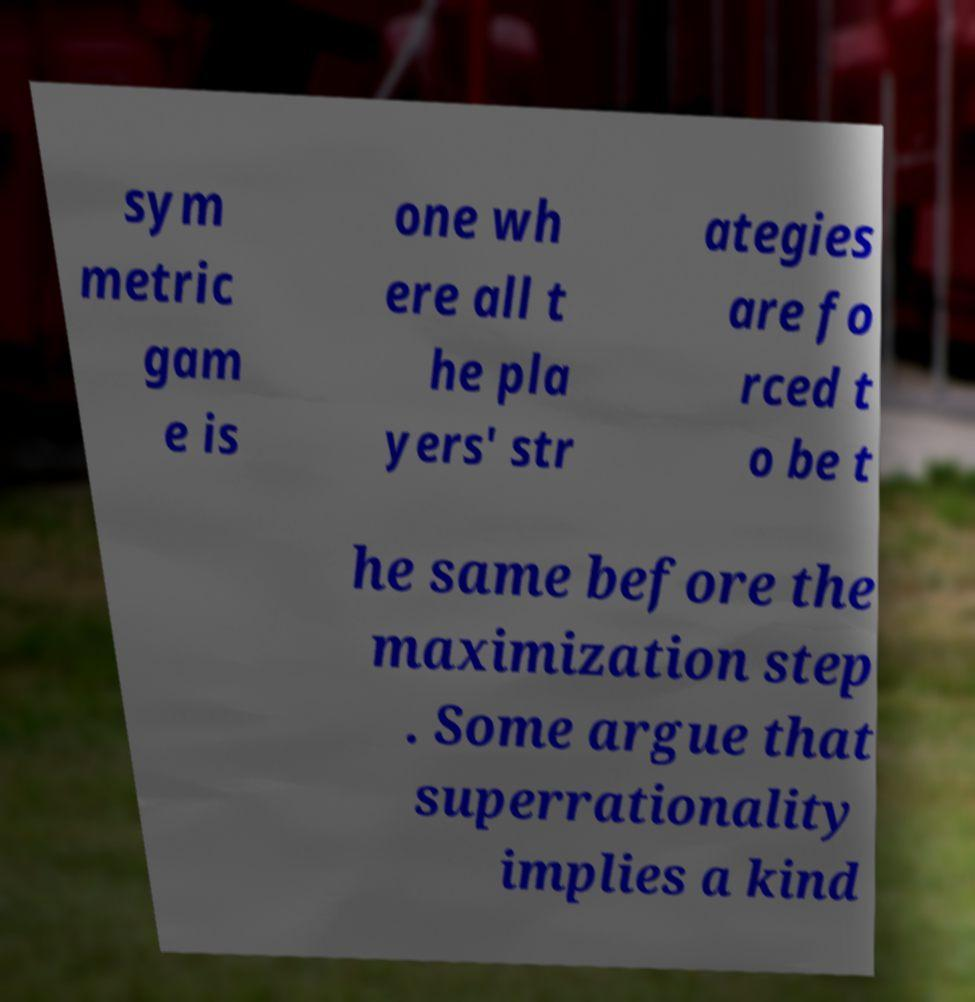Could you assist in decoding the text presented in this image and type it out clearly? sym metric gam e is one wh ere all t he pla yers' str ategies are fo rced t o be t he same before the maximization step . Some argue that superrationality implies a kind 